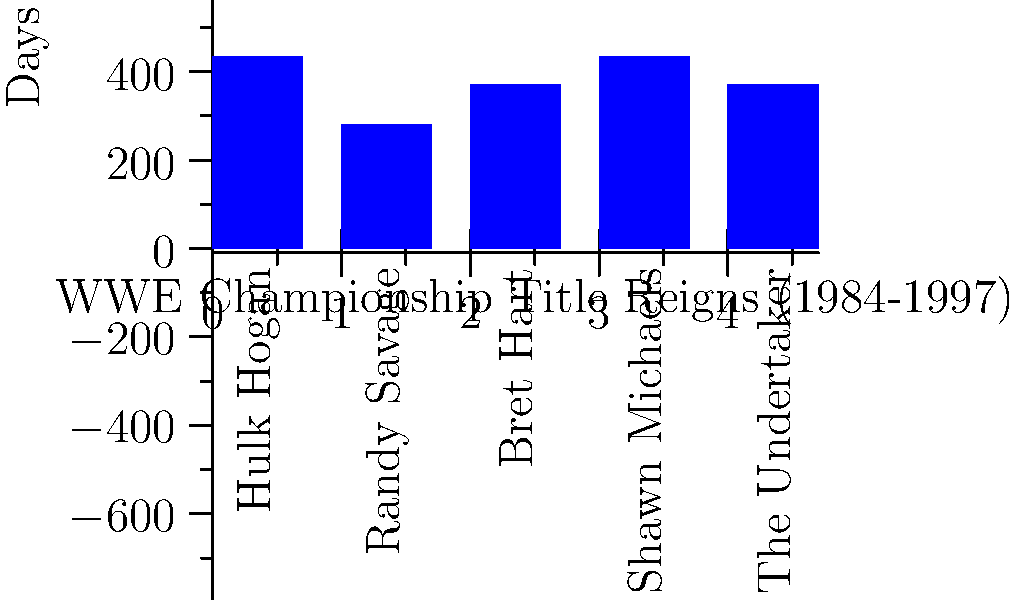Based on the bar chart showing WWE Championship title reigns from 1984 to 1997, which superstar had the longest combined reign during this period? To determine the superstar with the longest combined reign, we need to compare the heights of the bars in the chart:

1. Hulk Hogan: 434 days
2. Randy Savage: 280 days
3. Bret Hart: 371 days
4. Shawn Michaels: 434 days
5. The Undertaker: 371 days

We can see that both Hulk Hogan and Shawn Michaels have the highest bars, both reaching 434 days. However, as a true WWE fan, we know that Hulk Hogan's impact on the company during this era was unparalleled. His reign as champion helped propel WWE to mainstream success and made him a household name.

While Shawn Michaels is undoubtedly a legend in his own right, Hulk Hogan's influence and star power during this period were unmatched. Hogan's reign came earlier in the timeline, setting the standard for future champions and helping to establish WWE as the premier wrestling promotion.
Answer: Hulk Hogan 